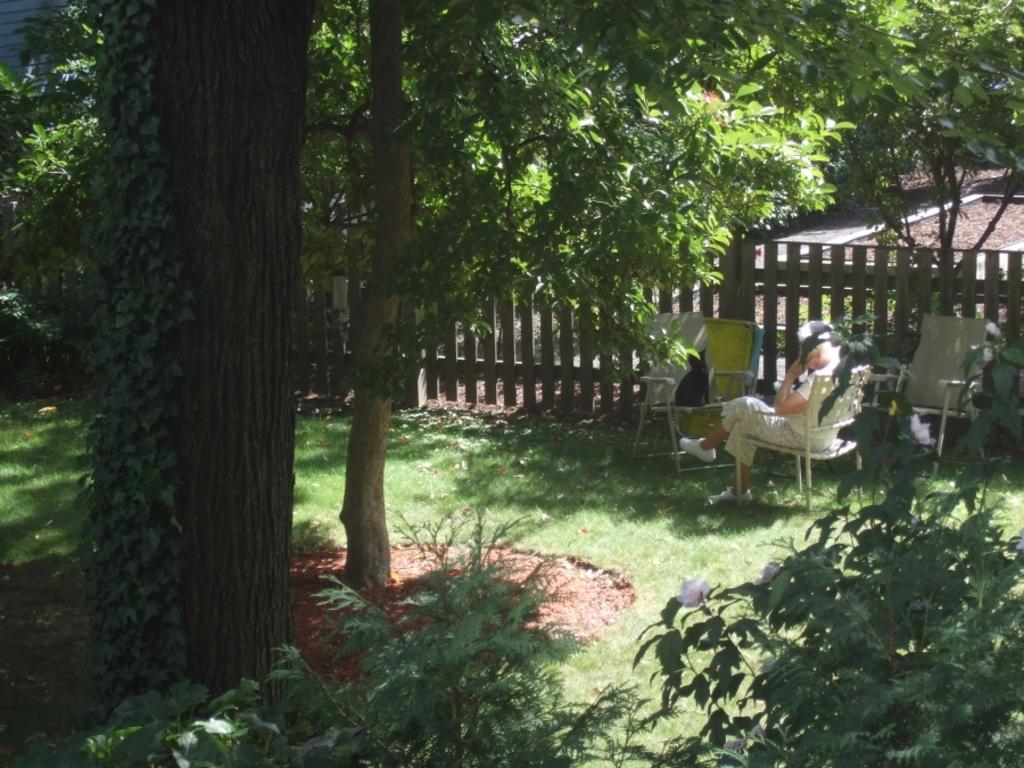What type of vegetation is present in the image? There are green color plants and trees in the image. Where is the person located in the image? The person is sitting on a chair at the right side of the image. What can be seen in the image that serves as a barrier or boundary? There is fencing in the image. What type of disease is affecting the plants in the image? There is no indication of any disease affecting the plants in the image; they appear to be healthy green plants and trees. What type of table is present in the image? There is no table present in the image. 